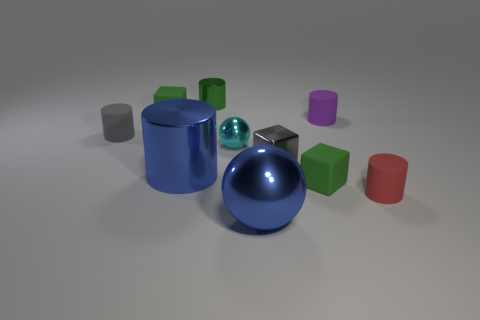There is a large metal ball; are there any red matte cylinders on the right side of it? Indeed, there is one small red matte cylinder situated to the right of the large metal ball amidst a collection of variously colored and shaped objects. 